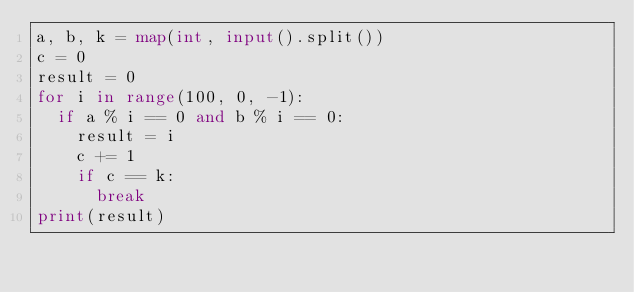<code> <loc_0><loc_0><loc_500><loc_500><_Python_>a, b, k = map(int, input().split())
c = 0
result = 0
for i in range(100, 0, -1):
  if a % i == 0 and b % i == 0:
    result = i
    c += 1
    if c == k:
      break
print(result)
</code> 